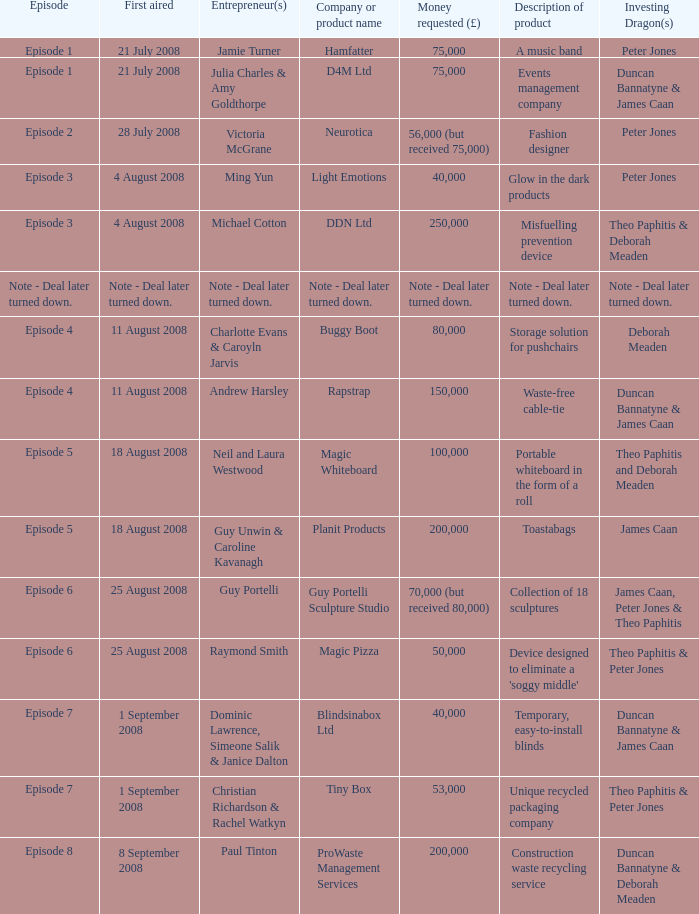When did episode 6 first air with entrepreneur Guy Portelli? 25 August 2008. 